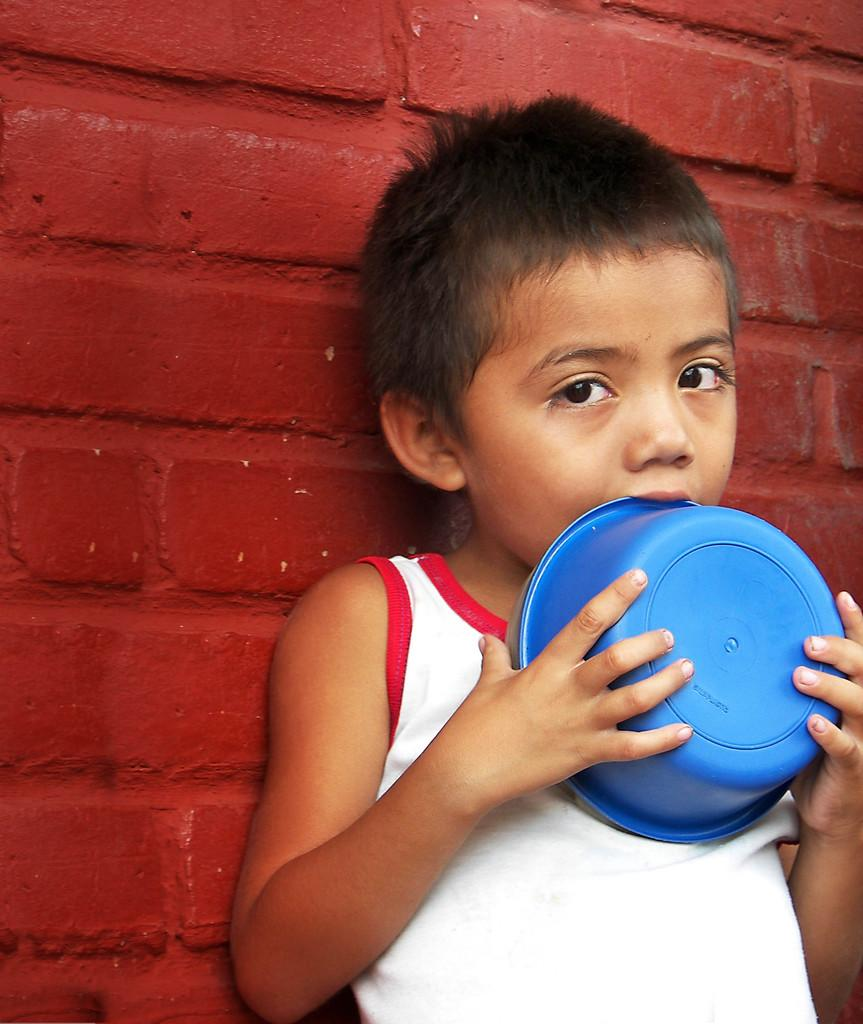Who is the main subject in the image? There is a boy in the image. What is the boy holding in the image? The boy is holding a blue bowl. What is the boy's focus in the image? The boy is looking at something. What can be seen in the background of the image? There is a red brick wall in the background of the image. How many legs does the volcano have in the image? There is no volcano present in the image, so it is not possible to determine how many legs it might have. 